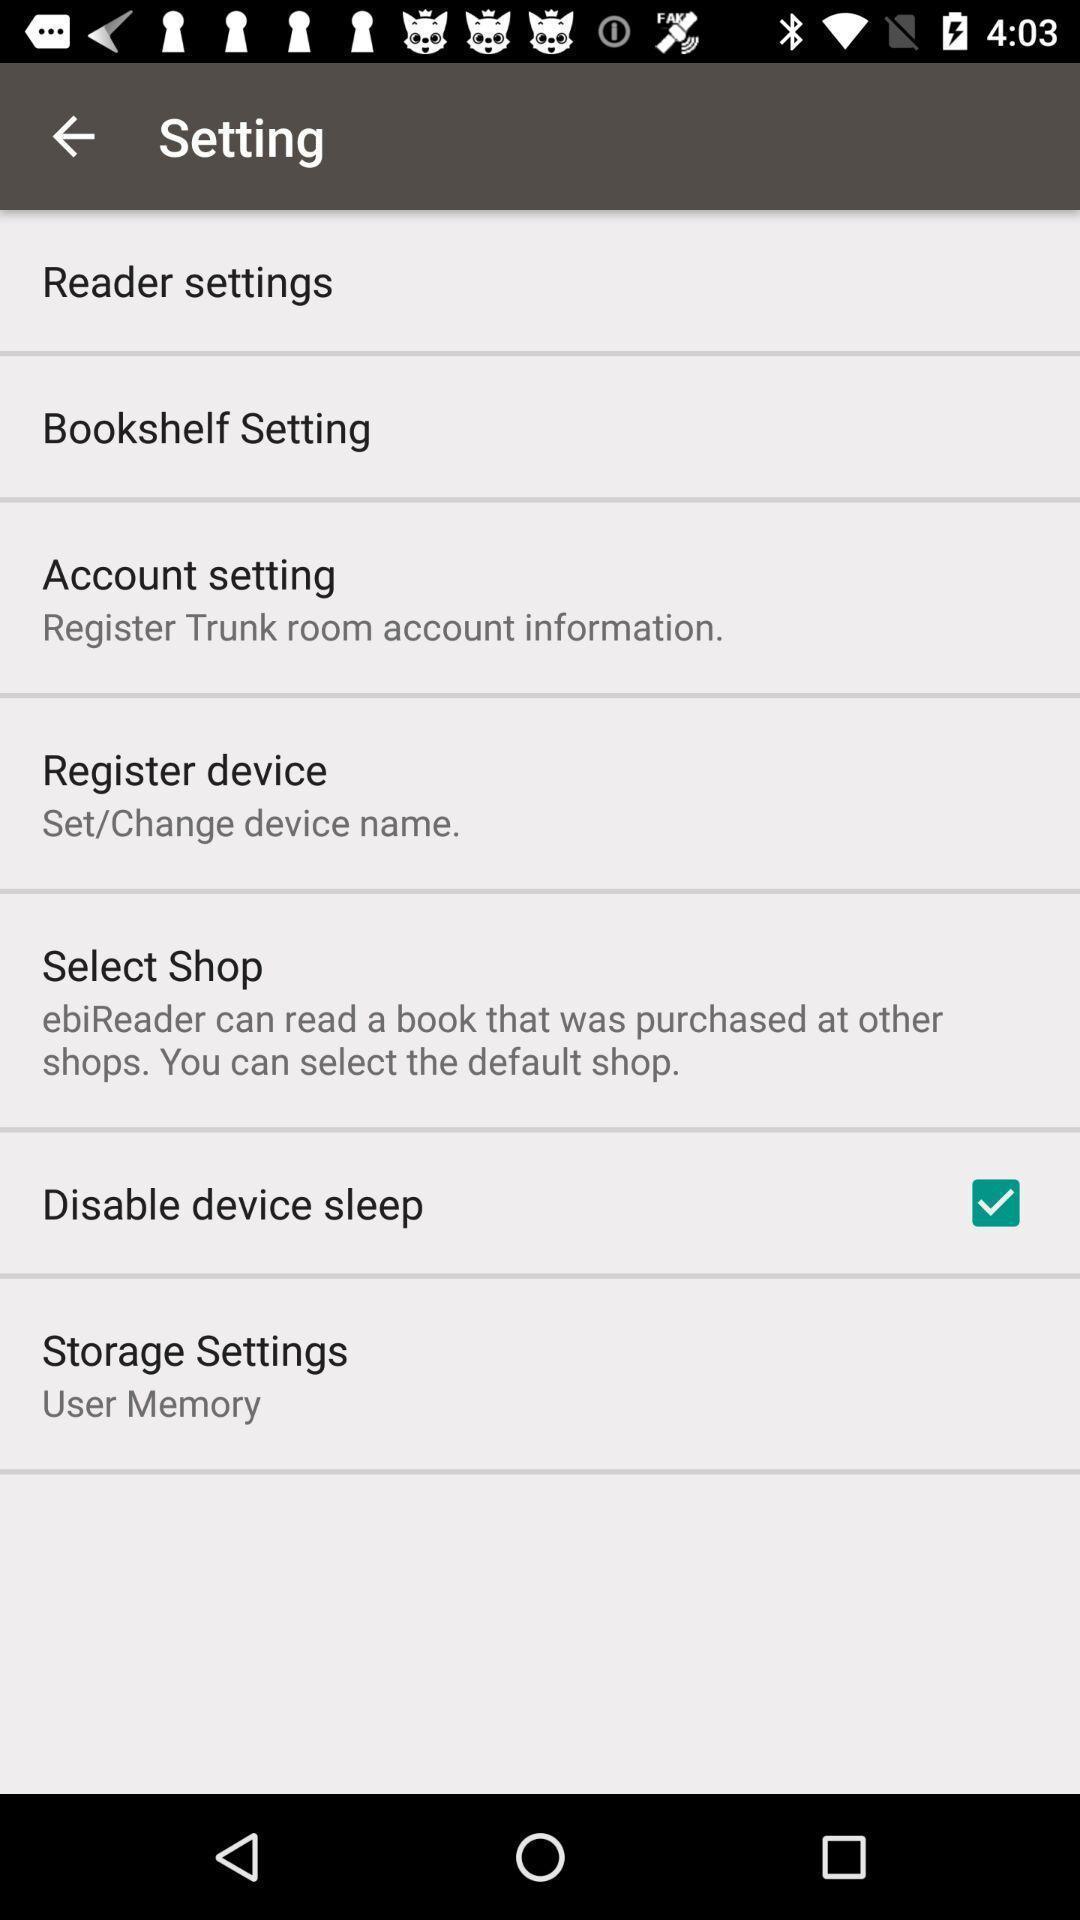Explain the elements present in this screenshot. Screen displaying list of options under settings. 